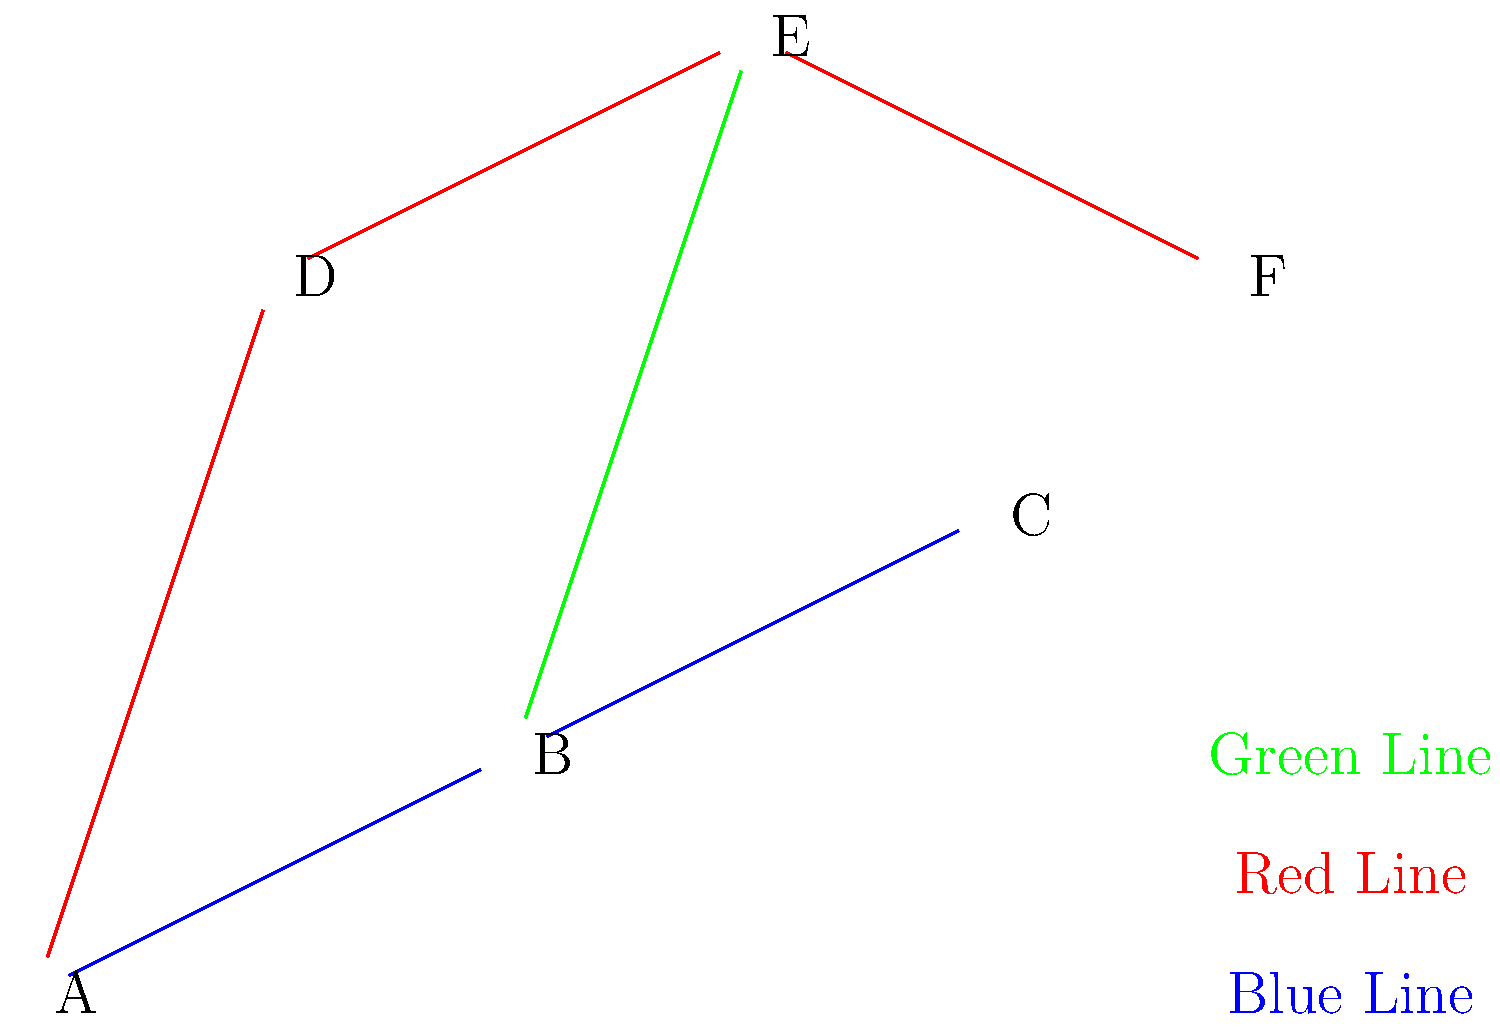You need to visit stations A, C, and F in the most efficient order. What is the optimal route and how many station stops will you make in total? Let's analyze the subway map and find the most efficient route:

1. We need to visit stations A, C, and F.
2. Starting from A:
   - To reach C: A → B → C (2 stops, blue line)
   - To reach F: A → D → E → F (3 stops, red line)
3. Starting from C:
   - To reach A: C → B → A (2 stops, blue line)
   - To reach F: C → B → E → F (3 stops, blue + green + red lines)
4. Starting from F:
   - To reach A: F → E → D → A (3 stops, red line)
   - To reach C: F → E → B → C (3 stops, red + green + blue lines)

5. The most efficient route is:
   A → B → C → B → E → F

6. Counting the stops:
   A to B: 1 stop
   B to C: 1 stop
   C to B: 1 stop
   B to E: 1 stop
   E to F: 1 stop
   Total: 5 stops

Therefore, the optimal route is A → B → C → B → E → F, with a total of 5 station stops.
Answer: A → B → C → B → E → F, 5 stops 